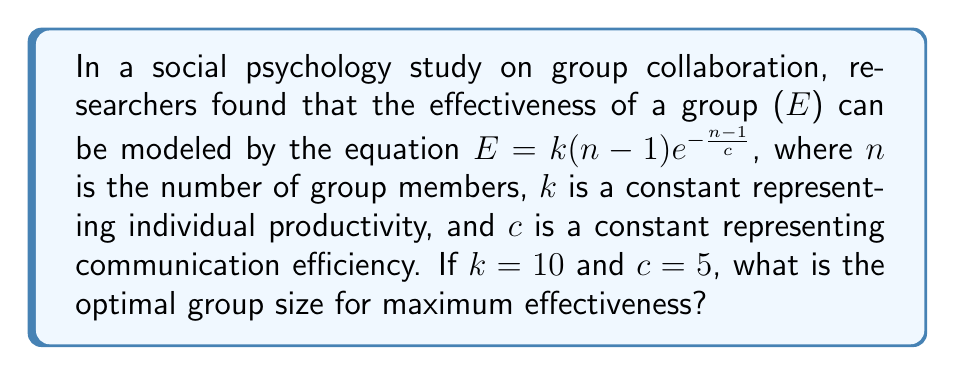Can you solve this math problem? To find the optimal group size, we need to maximize the effectiveness function $E$. We can do this by finding the value of $n$ where the derivative of $E$ with respect to $n$ is zero.

1) First, let's simplify our equation by substituting the given values:
   $E = 10(n-1)e^{-\frac{n-1}{5}}$

2) Now, let's take the derivative of $E$ with respect to $n$:
   $$\frac{dE}{dn} = 10e^{-\frac{n-1}{5}} + 10(n-1)e^{-\frac{n-1}{5}}(-\frac{1}{5})$$

3) Simplify:
   $$\frac{dE}{dn} = 10e^{-\frac{n-1}{5}}(1 - \frac{n-1}{5})$$

4) Set this equal to zero and solve:
   $$10e^{-\frac{n-1}{5}}(1 - \frac{n-1}{5}) = 0$$

5) The exponential term is always positive, so:
   $$1 - \frac{n-1}{5} = 0$$

6) Solve for $n$:
   $$\frac{n-1}{5} = 1$$
   $$n-1 = 5$$
   $$n = 6$$

7) To confirm this is a maximum, we could take the second derivative and show it's negative at $n=6$, but for brevity, we'll skip this step.

Therefore, the optimal group size for maximum effectiveness is 6 members.
Answer: 6 members 